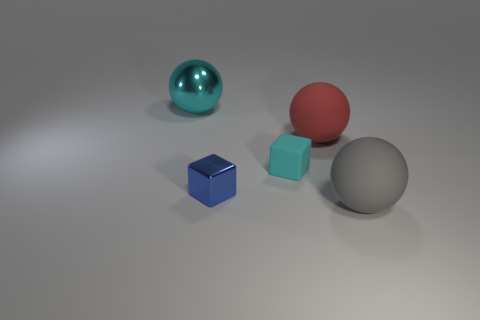Are there any blue rubber balls that have the same size as the red object?
Ensure brevity in your answer.  No. The gray rubber object has what size?
Ensure brevity in your answer.  Large. What number of other shiny blocks have the same size as the blue shiny cube?
Ensure brevity in your answer.  0. Is the number of large gray matte objects on the left side of the metallic block less than the number of red matte spheres behind the cyan matte cube?
Offer a terse response. Yes. There is a cyan thing that is in front of the large rubber object on the left side of the large sphere to the right of the big red thing; what size is it?
Give a very brief answer. Small. There is a sphere that is both on the right side of the tiny metallic object and behind the large gray ball; how big is it?
Your answer should be compact. Large. The large matte object behind the big object that is in front of the red matte thing is what shape?
Your response must be concise. Sphere. Is there any other thing that is the same color as the shiny cube?
Ensure brevity in your answer.  No. What is the shape of the rubber thing that is behind the tiny rubber block?
Offer a terse response. Sphere. There is a rubber object that is both in front of the red ball and behind the big gray object; what is its shape?
Offer a terse response. Cube. 